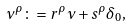Convert formula to latex. <formula><loc_0><loc_0><loc_500><loc_500>\nu ^ { \rho } \colon = r ^ { \rho } \nu + s ^ { \rho } \delta _ { 0 } ,</formula> 